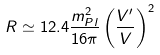Convert formula to latex. <formula><loc_0><loc_0><loc_500><loc_500>R \simeq 1 2 . 4 \frac { m _ { P l } ^ { 2 } } { 1 6 \pi } \left ( \frac { V ^ { \prime } } { V } \right ) ^ { 2 }</formula> 